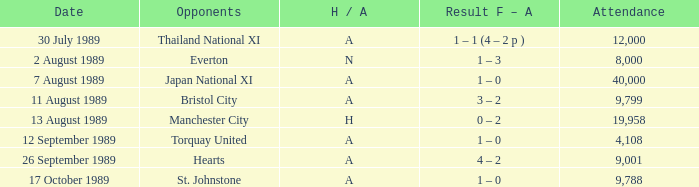How many individuals were present at the manchester united versus hearts match? 9001.0. 